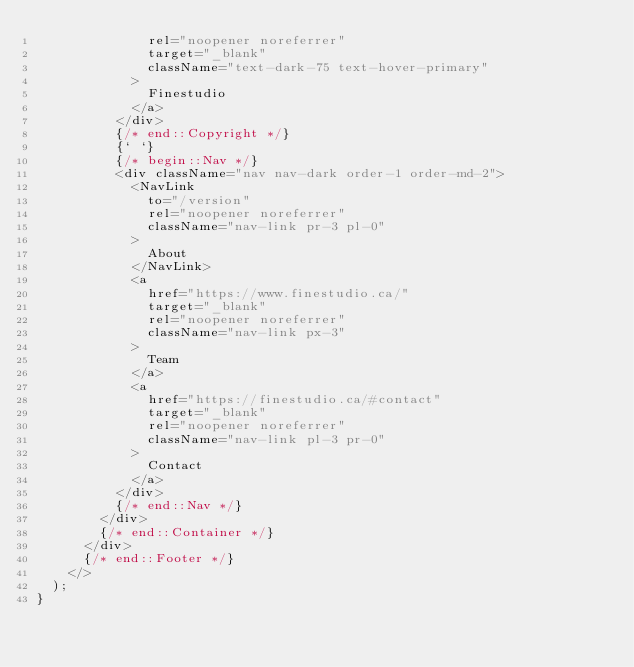Convert code to text. <code><loc_0><loc_0><loc_500><loc_500><_JavaScript_>              rel="noopener noreferrer"
              target="_blank"
              className="text-dark-75 text-hover-primary"
            >
              Finestudio
            </a>
          </div>
          {/* end::Copyright */}
          {` `}
          {/* begin::Nav */}
          <div className="nav nav-dark order-1 order-md-2">
            <NavLink
              to="/version"
              rel="noopener noreferrer"
              className="nav-link pr-3 pl-0"
            >
              About
            </NavLink>
            <a
              href="https://www.finestudio.ca/"
              target="_blank"
              rel="noopener noreferrer"
              className="nav-link px-3"
            >
              Team
            </a>
            <a
              href="https://finestudio.ca/#contact"
              target="_blank"
              rel="noopener noreferrer"
              className="nav-link pl-3 pr-0"
            >
              Contact
            </a>
          </div>
          {/* end::Nav */}
        </div>
        {/* end::Container */}
      </div>
      {/* end::Footer */}
    </>
  );
}
</code> 